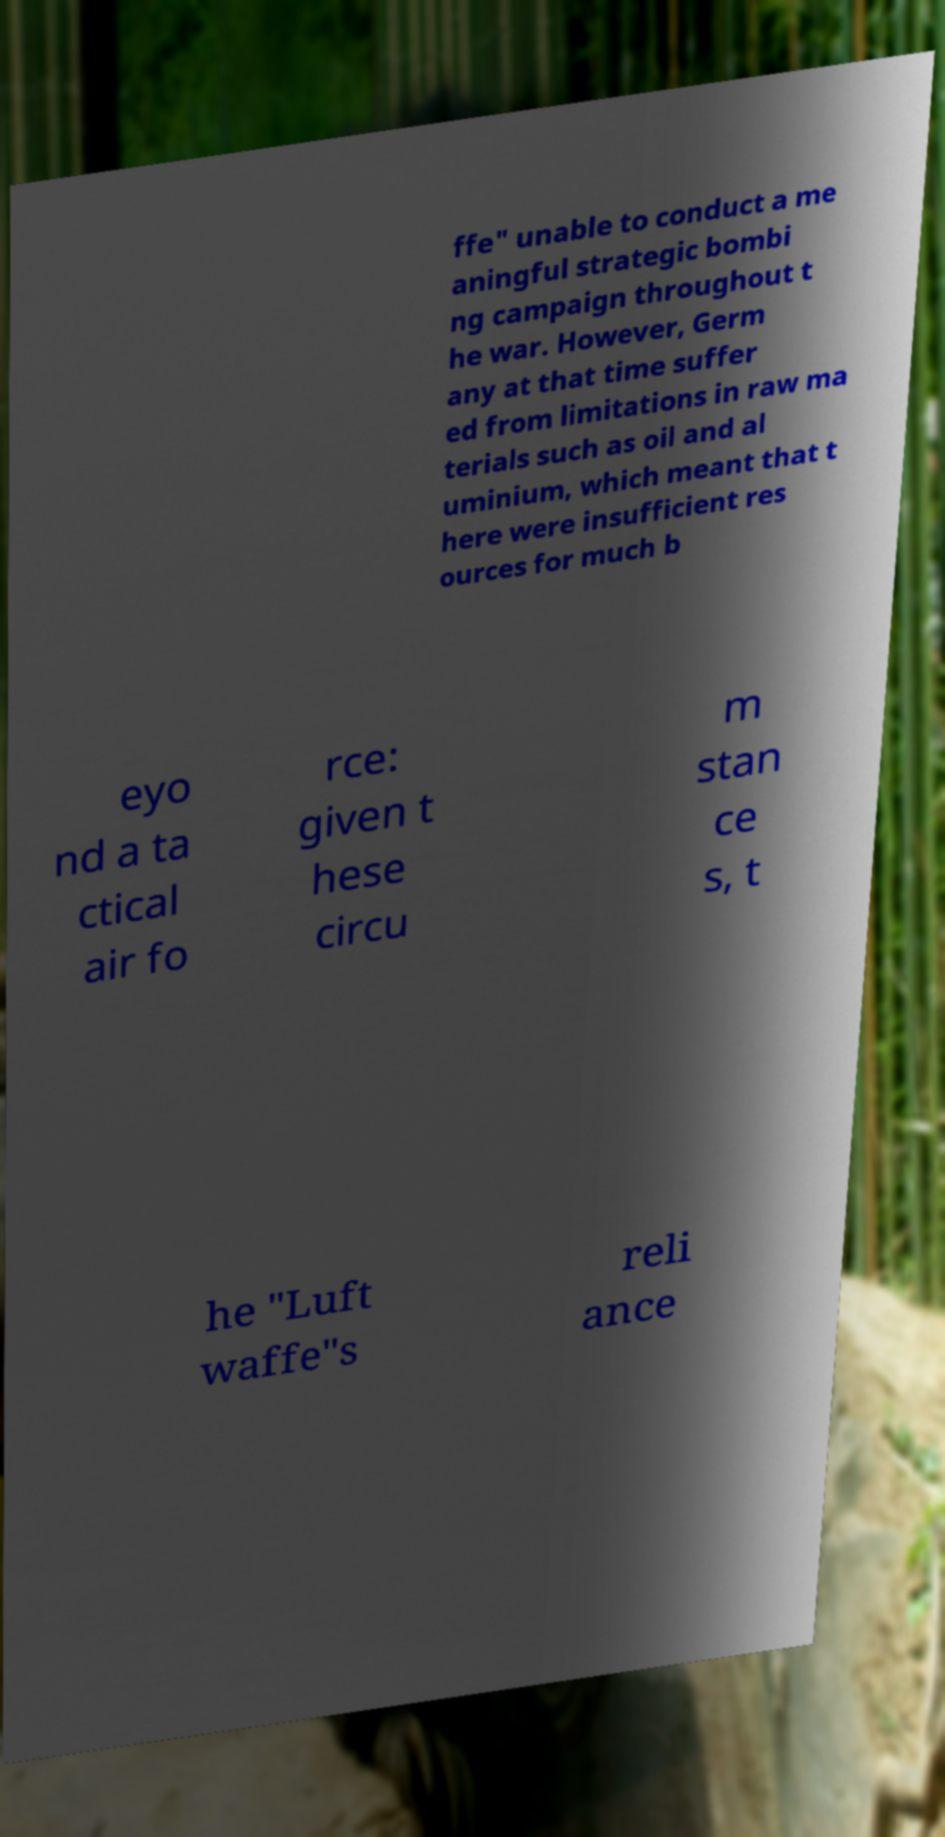Please read and relay the text visible in this image. What does it say? ffe" unable to conduct a me aningful strategic bombi ng campaign throughout t he war. However, Germ any at that time suffer ed from limitations in raw ma terials such as oil and al uminium, which meant that t here were insufficient res ources for much b eyo nd a ta ctical air fo rce: given t hese circu m stan ce s, t he "Luft waffe"s reli ance 